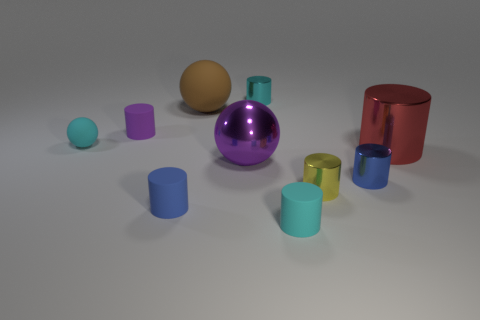What is the size of the cyan sphere that is the same material as the brown ball?
Your answer should be compact. Small. What number of cyan objects are either small metal cylinders or large metallic cylinders?
Provide a succinct answer. 1. There is a cylinder behind the big rubber ball; what number of small cylinders are behind it?
Your response must be concise. 0. Is the number of cyan rubber cylinders to the right of the yellow shiny cylinder greater than the number of metallic spheres that are behind the tiny cyan metallic object?
Give a very brief answer. No. What is the material of the red cylinder?
Your answer should be very brief. Metal. Are there any rubber spheres that have the same size as the blue metallic thing?
Your response must be concise. Yes. There is a ball that is the same size as the yellow metallic cylinder; what is it made of?
Offer a very short reply. Rubber. What number of big yellow things are there?
Ensure brevity in your answer.  0. How big is the shiny cylinder right of the small blue metallic cylinder?
Your answer should be very brief. Large. Are there an equal number of small metal cylinders in front of the small purple rubber thing and big brown matte balls?
Your answer should be compact. No. 